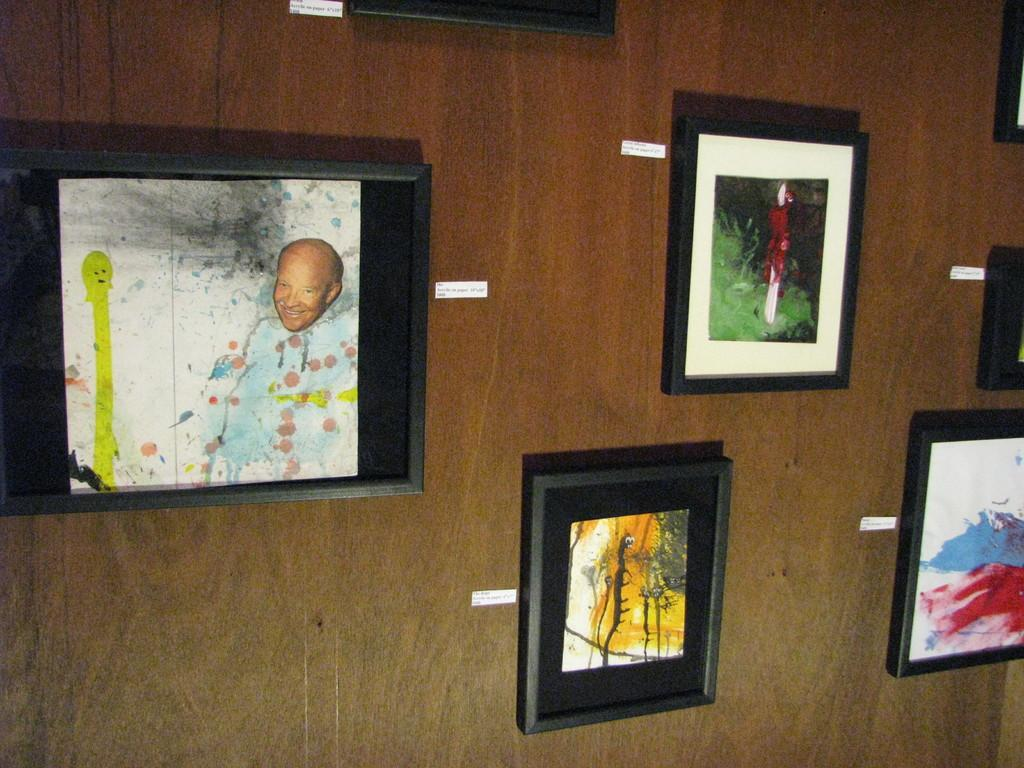What can be seen in the image? There are frames in the image. What is the frames attached to? The frames are attached to a brown color surface. How does the toe express regret in the image? There is no toe or expression of regret present in the image; it only features frames attached to a brown color surface. 